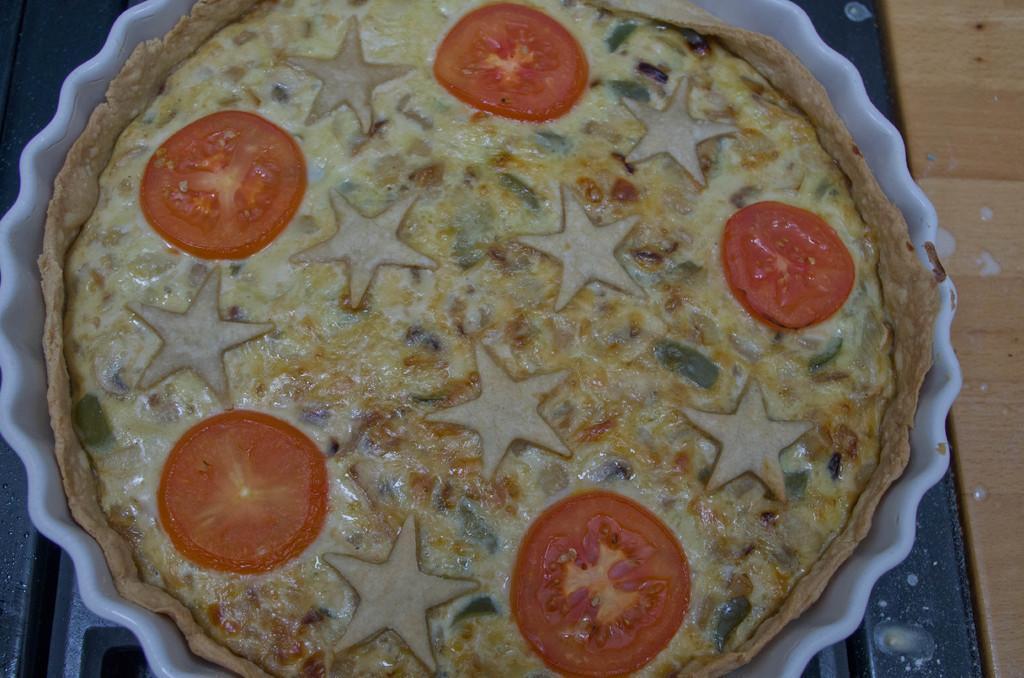Please provide a concise description of this image. In the foreground of this image, there is a food item on which tomatoes are placed in a bowl and in the background, we see the surface. 